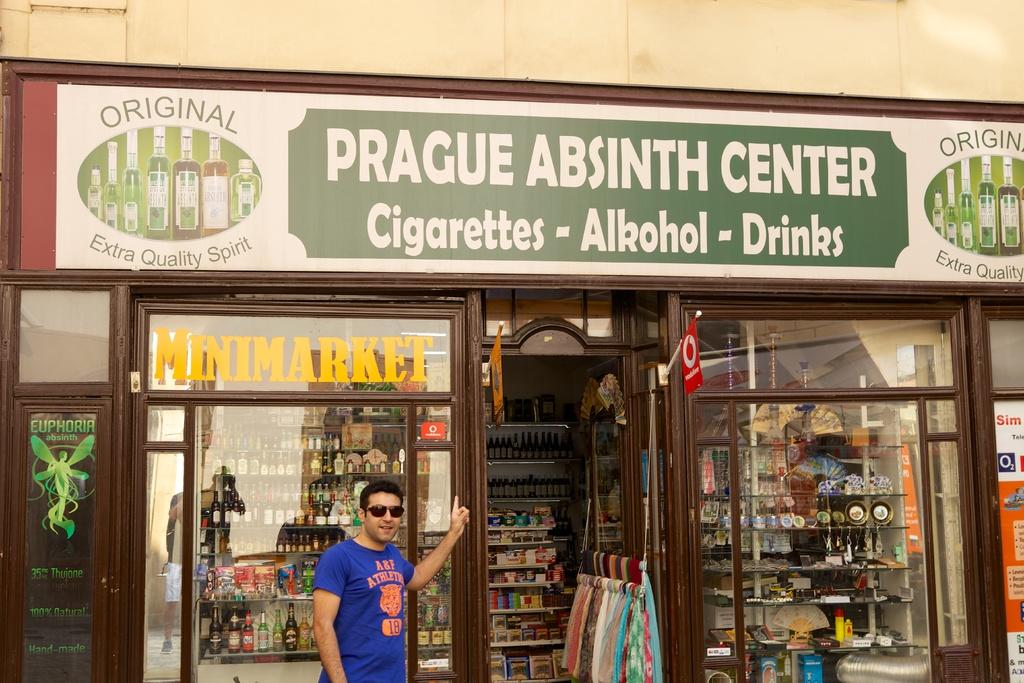Does this shop sell cigarettes?
Your answer should be very brief. Yes. What is the name of this store?
Offer a terse response. Prague absinth center. 